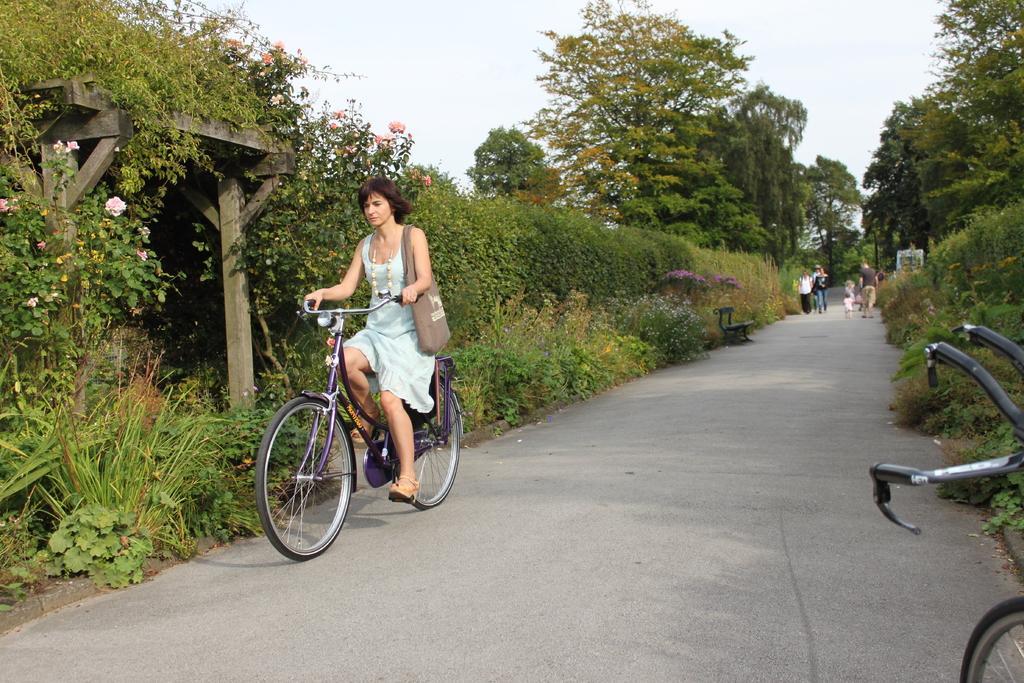Describe this image in one or two sentences. In this picture there is a woman riding a bicycle on the road. There are some plants and trees in the background and we can observe a sky here. 